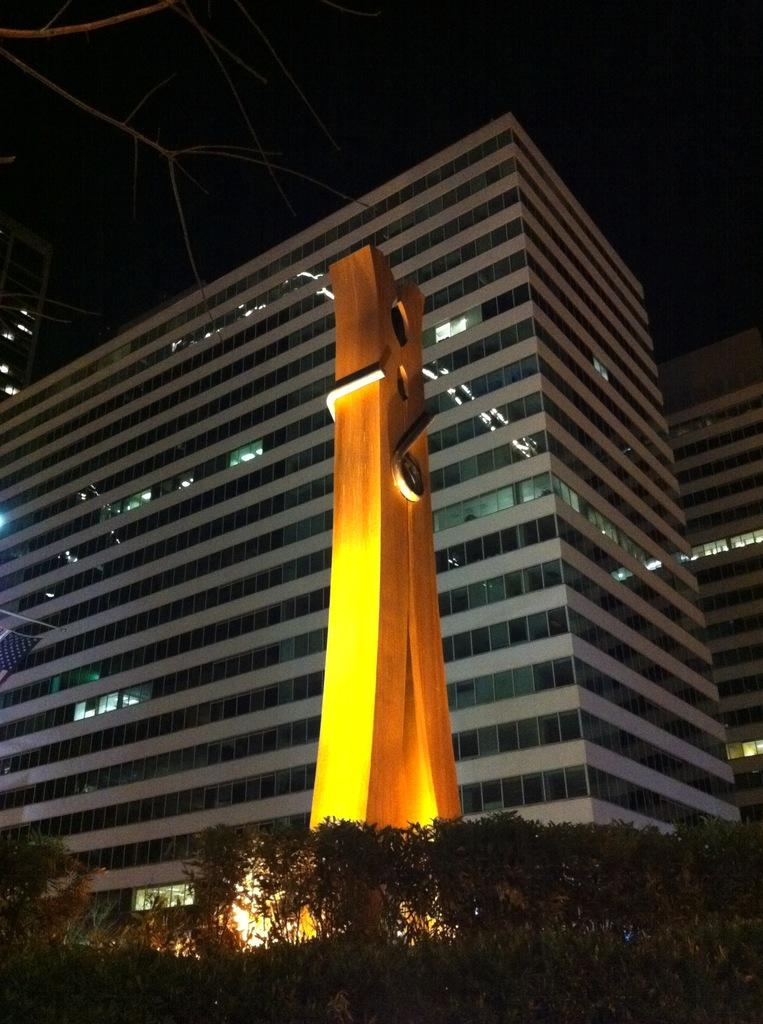What is the main subject in the center of the image? There is a statue in the center of the image. What can be seen in the foreground of the image? There is a group of trees in the foreground. What is visible in the background of the image? There is a building and the sky in the background. What type of ink is being used to write on the statue in the image? There is no ink or writing present on the statue in the image. How does the statue express love in the image? The statue does not express love in the image; it is a stationary object. 